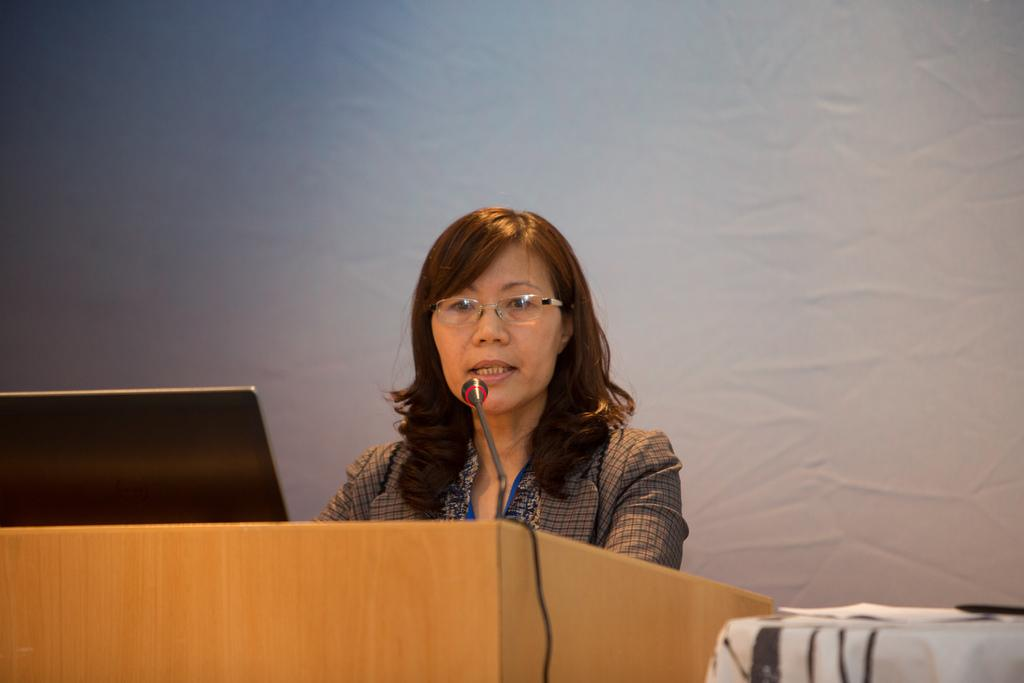Who is the main subject in the image? There is a woman in the image. Where is the woman located in the image? The woman is in the middle of the image. What objects are in front of the woman? There is a microphone and a podium in front of the woman. What accessory is the woman wearing? The woman is wearing spectacles. How many clocks are visible on the podium in the image? There are no clocks visible on the podium in the image. What idea does the woman have about the topic she is discussing? The image does not provide any information about the woman's ideas or the topic she is discussing. 